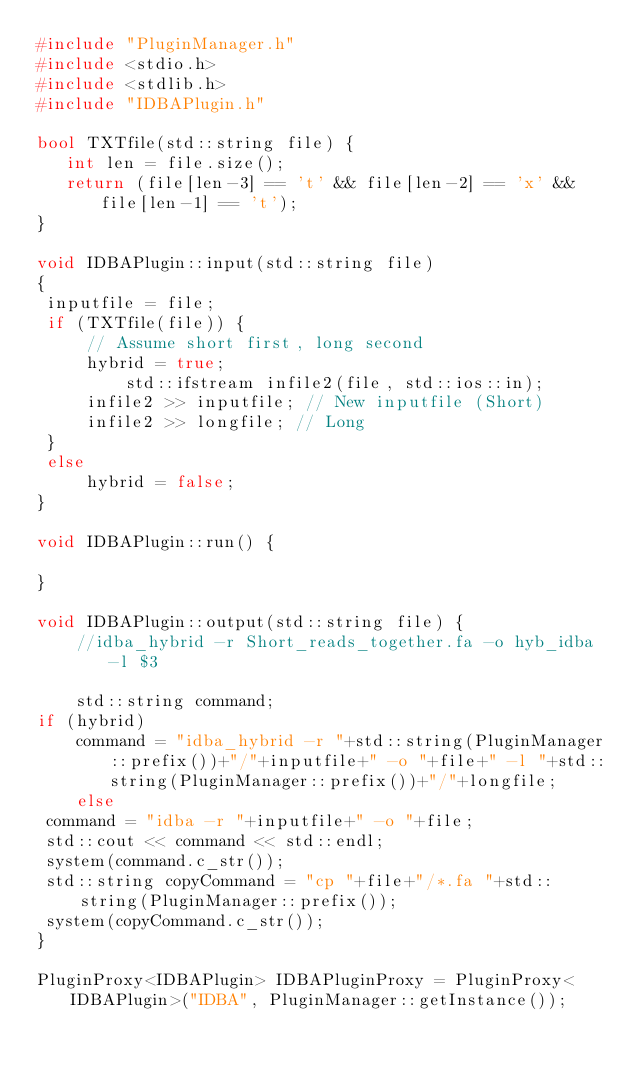<code> <loc_0><loc_0><loc_500><loc_500><_C++_>#include "PluginManager.h"
#include <stdio.h>
#include <stdlib.h>
#include "IDBAPlugin.h"

bool TXTfile(std::string file) {
   int len = file.size();
   return (file[len-3] == 't' && file[len-2] == 'x' && file[len-1] == 't');
}

void IDBAPlugin::input(std::string file) 
{
 inputfile = file;
 if (TXTfile(file)) {
	 // Assume short first, long second
	 hybrid = true;
         std::ifstream infile2(file, std::ios::in);
	 infile2 >> inputfile; // New inputfile (Short)
	 infile2 >> longfile; // Long
 }
 else
	 hybrid = false;
}

void IDBAPlugin::run() {
   
}

void IDBAPlugin::output(std::string file) {
	//idba_hybrid -r Short_reads_together.fa -o hyb_idba -l $3

	std::string command;
if (hybrid)
	command = "idba_hybrid -r "+std::string(PluginManager::prefix())+"/"+inputfile+" -o "+file+" -l "+std::string(PluginManager::prefix())+"/"+longfile;
	else 
 command = "idba -r "+inputfile+" -o "+file;
 std::cout << command << std::endl;
 system(command.c_str());
 std::string copyCommand = "cp "+file+"/*.fa "+std::string(PluginManager::prefix());
 system(copyCommand.c_str());
}

PluginProxy<IDBAPlugin> IDBAPluginProxy = PluginProxy<IDBAPlugin>("IDBA", PluginManager::getInstance());
</code> 